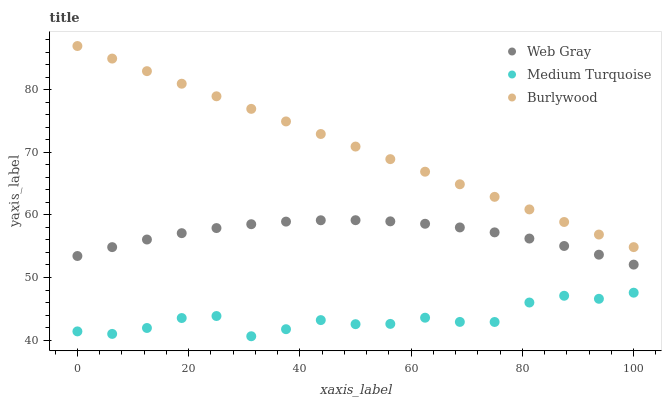Does Medium Turquoise have the minimum area under the curve?
Answer yes or no. Yes. Does Burlywood have the maximum area under the curve?
Answer yes or no. Yes. Does Web Gray have the minimum area under the curve?
Answer yes or no. No. Does Web Gray have the maximum area under the curve?
Answer yes or no. No. Is Burlywood the smoothest?
Answer yes or no. Yes. Is Medium Turquoise the roughest?
Answer yes or no. Yes. Is Web Gray the smoothest?
Answer yes or no. No. Is Web Gray the roughest?
Answer yes or no. No. Does Medium Turquoise have the lowest value?
Answer yes or no. Yes. Does Web Gray have the lowest value?
Answer yes or no. No. Does Burlywood have the highest value?
Answer yes or no. Yes. Does Web Gray have the highest value?
Answer yes or no. No. Is Medium Turquoise less than Burlywood?
Answer yes or no. Yes. Is Web Gray greater than Medium Turquoise?
Answer yes or no. Yes. Does Medium Turquoise intersect Burlywood?
Answer yes or no. No. 